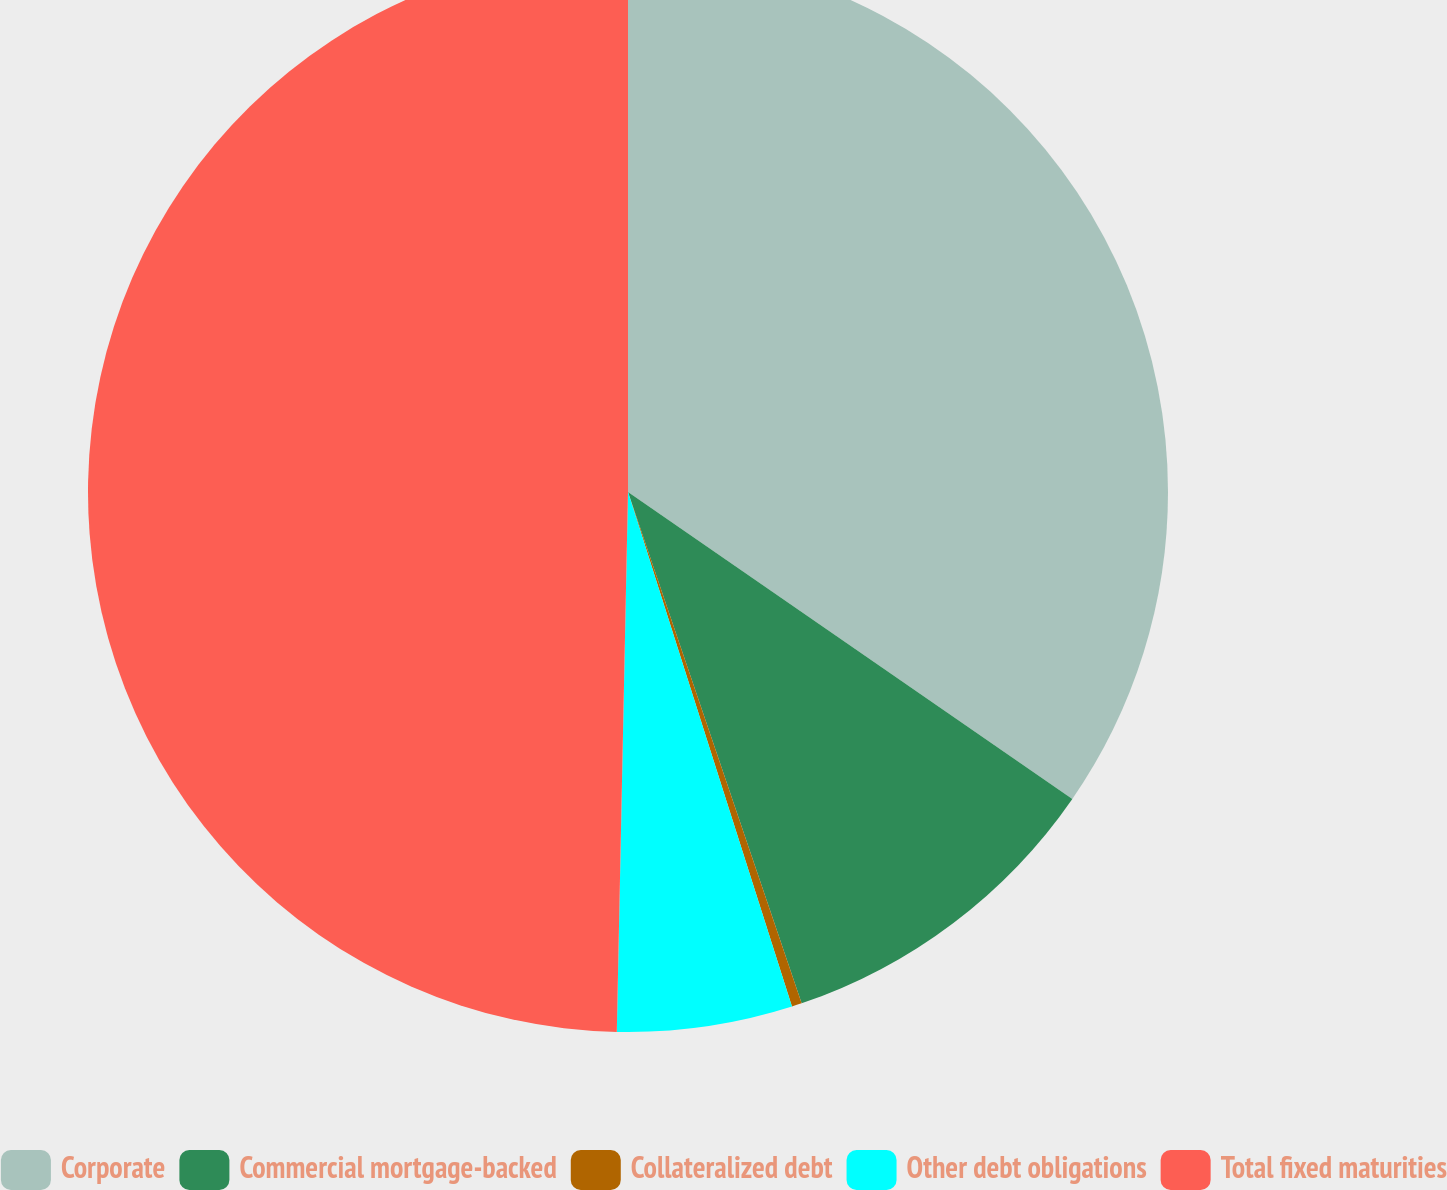Convert chart to OTSL. <chart><loc_0><loc_0><loc_500><loc_500><pie_chart><fcel>Corporate<fcel>Commercial mortgage-backed<fcel>Collateralized debt<fcel>Other debt obligations<fcel>Total fixed maturities<nl><fcel>34.62%<fcel>10.17%<fcel>0.3%<fcel>5.24%<fcel>49.67%<nl></chart> 